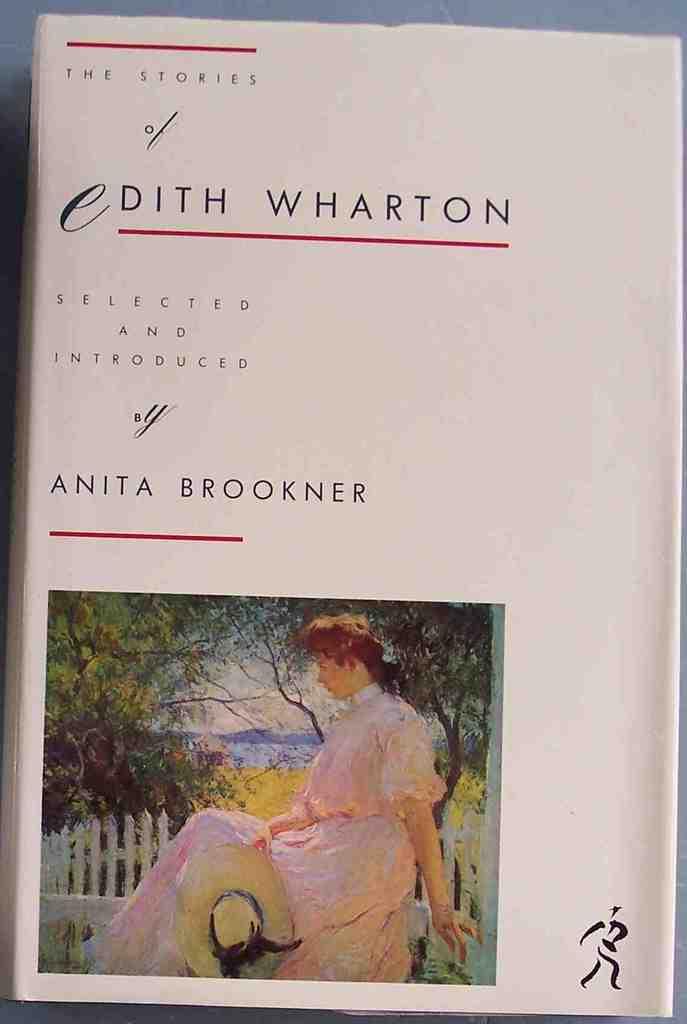Who is the author?
Provide a short and direct response. Anita brookner. 